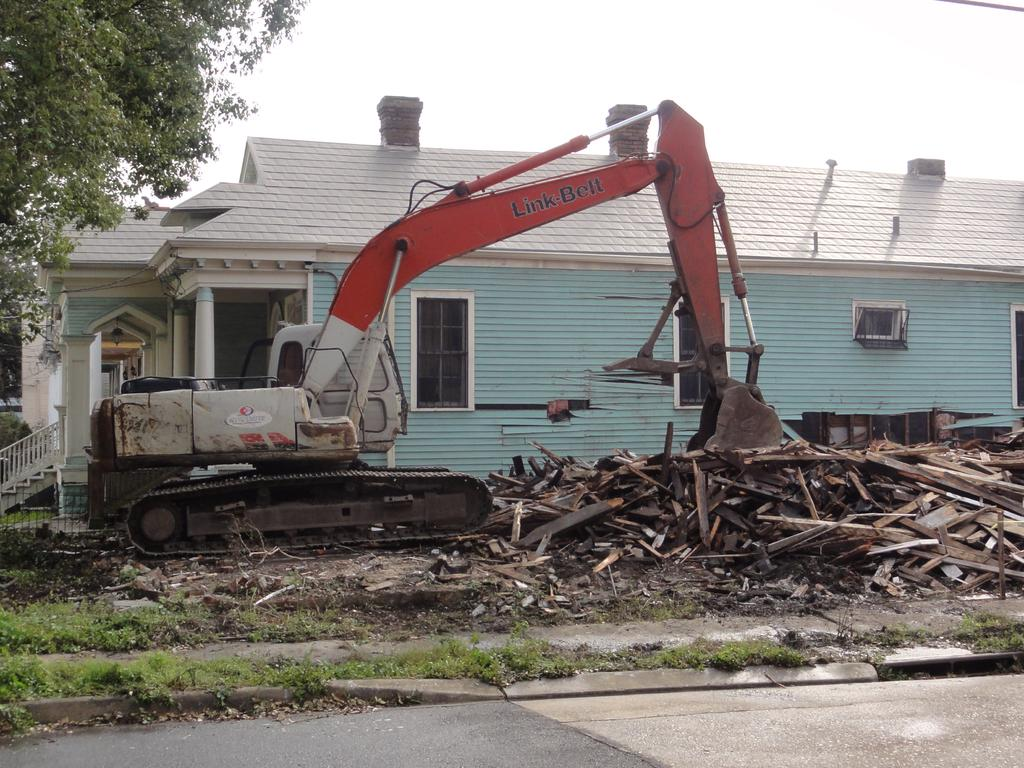What type of structure is visible in the picture? There is a house in the picture. What else can be seen besides the house? There is a vehicle and a tree in the picture. Are there any signs of damage or debris in the image? Yes, there are broken pieces of wood in the picture. What type of brain is visible in the picture? There is no brain visible in the picture; the image features a house, a vehicle, a tree, and broken pieces of wood. 